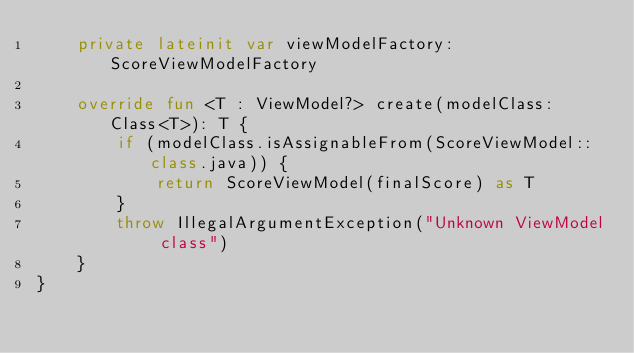<code> <loc_0><loc_0><loc_500><loc_500><_Kotlin_>    private lateinit var viewModelFactory: ScoreViewModelFactory

    override fun <T : ViewModel?> create(modelClass: Class<T>): T {
        if (modelClass.isAssignableFrom(ScoreViewModel::class.java)) {
            return ScoreViewModel(finalScore) as T
        }
        throw IllegalArgumentException("Unknown ViewModel class")
    }
}</code> 